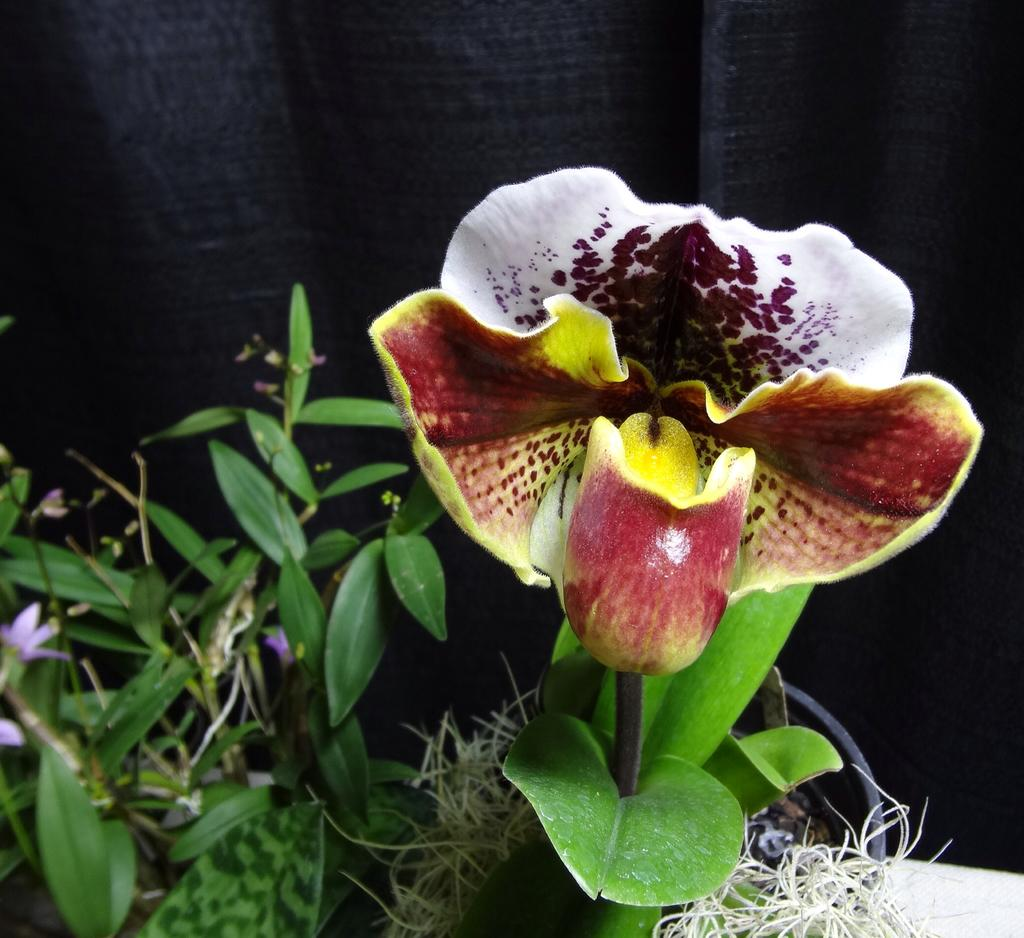What type of living organisms can be seen in the image? Plants and flowers are visible in the image. What is the color of the plants in the image? The plants are green in color. What colors can be seen in the flowers in the image? The flowers have various colors, including pink, maroon, yellow, brown, and white. What is the color of the background in the image? The background of the image is black in color. What type of profession does the lawyer have in the image? There is no lawyer present in the image; it features plants and flowers. What type of profession does the fireman have in the image? There is no fireman present in the image; it features plants and flowers. What type of profession does the writer have in the image? There is no writer present in the image; it features plants and flowers. 